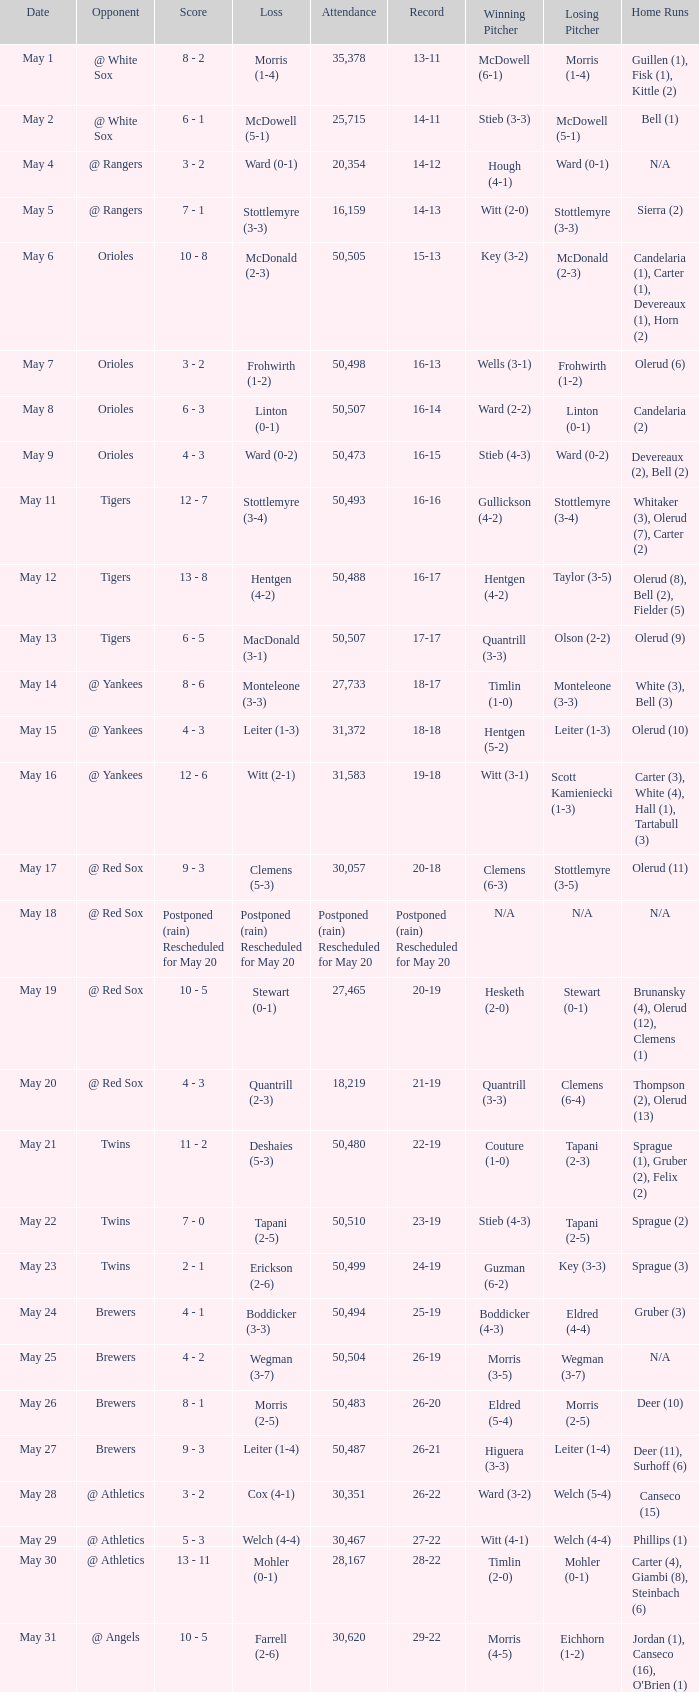On what date was their record 26-19? May 25. 